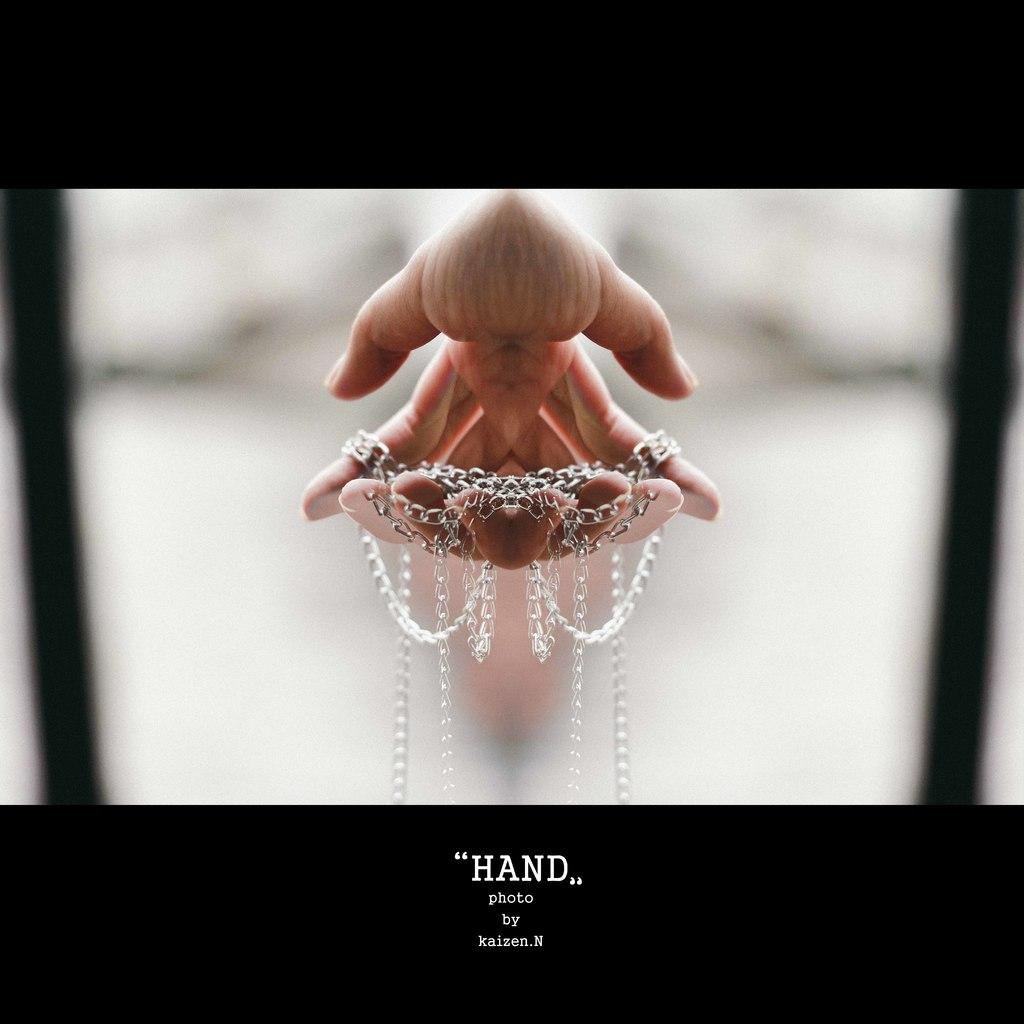What is the main subject of the image? The main subject of the image is a photograph. What can be seen in the photograph? There are hands and a chain in the photograph. How does the photograph appear? The photograph appears to be edited. What is written at the bottom of the image? There is text at the bottom of the image. Can you see a kite flying in the background of the photograph? There is no kite visible in the photograph; it only contains hands and a chain. Who is the friend in the photograph? There is no friend present in the photograph; it only shows hands and a chain. 